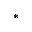Convert formula to latex. <formula><loc_0><loc_0><loc_500><loc_500>^ { * }</formula> 